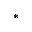Convert formula to latex. <formula><loc_0><loc_0><loc_500><loc_500>^ { * }</formula> 